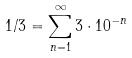<formula> <loc_0><loc_0><loc_500><loc_500>1 / 3 = \sum _ { n = 1 } ^ { \infty } 3 \cdot 1 0 ^ { - n }</formula> 